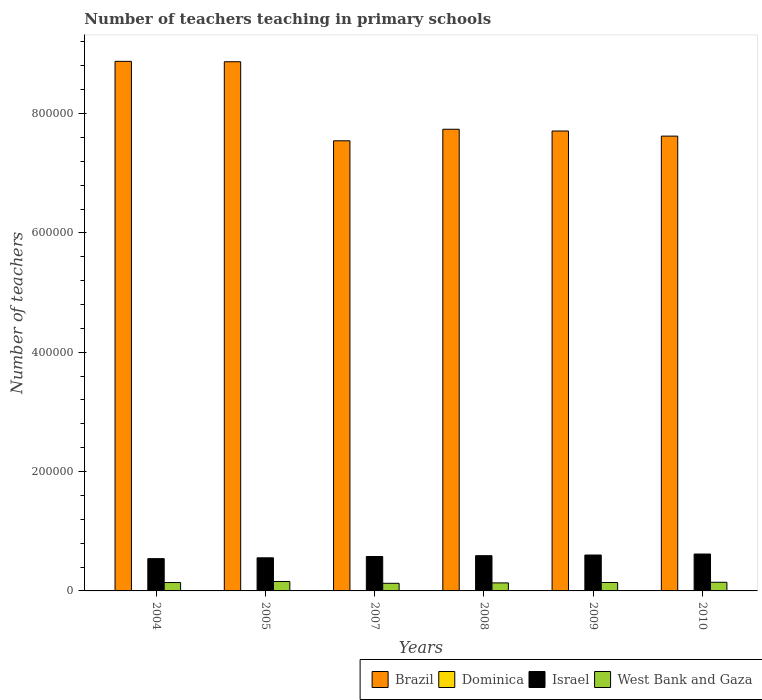Are the number of bars per tick equal to the number of legend labels?
Offer a terse response. Yes. Are the number of bars on each tick of the X-axis equal?
Provide a succinct answer. Yes. How many bars are there on the 6th tick from the right?
Ensure brevity in your answer.  4. What is the label of the 6th group of bars from the left?
Keep it short and to the point. 2010. What is the number of teachers teaching in primary schools in West Bank and Gaza in 2007?
Your response must be concise. 1.28e+04. Across all years, what is the maximum number of teachers teaching in primary schools in Dominica?
Ensure brevity in your answer.  519. Across all years, what is the minimum number of teachers teaching in primary schools in Dominica?
Give a very brief answer. 499. In which year was the number of teachers teaching in primary schools in West Bank and Gaza minimum?
Keep it short and to the point. 2007. What is the total number of teachers teaching in primary schools in Brazil in the graph?
Ensure brevity in your answer.  4.83e+06. What is the difference between the number of teachers teaching in primary schools in Brazil in 2005 and that in 2007?
Provide a short and direct response. 1.32e+05. What is the difference between the number of teachers teaching in primary schools in Brazil in 2005 and the number of teachers teaching in primary schools in Israel in 2009?
Your answer should be compact. 8.27e+05. What is the average number of teachers teaching in primary schools in Dominica per year?
Your answer should be very brief. 509.17. In the year 2005, what is the difference between the number of teachers teaching in primary schools in West Bank and Gaza and number of teachers teaching in primary schools in Israel?
Your answer should be compact. -3.97e+04. What is the ratio of the number of teachers teaching in primary schools in West Bank and Gaza in 2004 to that in 2010?
Ensure brevity in your answer.  0.97. What is the difference between the highest and the second highest number of teachers teaching in primary schools in Israel?
Give a very brief answer. 1675. What is the difference between the highest and the lowest number of teachers teaching in primary schools in Brazil?
Provide a short and direct response. 1.33e+05. Is the sum of the number of teachers teaching in primary schools in Israel in 2005 and 2007 greater than the maximum number of teachers teaching in primary schools in Brazil across all years?
Ensure brevity in your answer.  No. Is it the case that in every year, the sum of the number of teachers teaching in primary schools in West Bank and Gaza and number of teachers teaching in primary schools in Dominica is greater than the sum of number of teachers teaching in primary schools in Brazil and number of teachers teaching in primary schools in Israel?
Offer a terse response. No. What does the 2nd bar from the left in 2007 represents?
Keep it short and to the point. Dominica. What does the 1st bar from the right in 2007 represents?
Provide a short and direct response. West Bank and Gaza. How many bars are there?
Offer a very short reply. 24. How many years are there in the graph?
Make the answer very short. 6. Does the graph contain any zero values?
Offer a very short reply. No. Does the graph contain grids?
Your answer should be very brief. No. What is the title of the graph?
Offer a very short reply. Number of teachers teaching in primary schools. What is the label or title of the Y-axis?
Your response must be concise. Number of teachers. What is the Number of teachers in Brazil in 2004?
Provide a succinct answer. 8.87e+05. What is the Number of teachers of Dominica in 2004?
Offer a terse response. 519. What is the Number of teachers in Israel in 2004?
Your answer should be compact. 5.41e+04. What is the Number of teachers in West Bank and Gaza in 2004?
Keep it short and to the point. 1.40e+04. What is the Number of teachers in Brazil in 2005?
Ensure brevity in your answer.  8.87e+05. What is the Number of teachers of Dominica in 2005?
Your answer should be very brief. 519. What is the Number of teachers in Israel in 2005?
Ensure brevity in your answer.  5.55e+04. What is the Number of teachers in West Bank and Gaza in 2005?
Keep it short and to the point. 1.58e+04. What is the Number of teachers of Brazil in 2007?
Your response must be concise. 7.54e+05. What is the Number of teachers in Dominica in 2007?
Keep it short and to the point. 499. What is the Number of teachers of Israel in 2007?
Offer a very short reply. 5.77e+04. What is the Number of teachers in West Bank and Gaza in 2007?
Ensure brevity in your answer.  1.28e+04. What is the Number of teachers in Brazil in 2008?
Provide a succinct answer. 7.74e+05. What is the Number of teachers in Israel in 2008?
Keep it short and to the point. 5.91e+04. What is the Number of teachers of West Bank and Gaza in 2008?
Offer a terse response. 1.34e+04. What is the Number of teachers of Brazil in 2009?
Give a very brief answer. 7.71e+05. What is the Number of teachers of Dominica in 2009?
Ensure brevity in your answer.  510. What is the Number of teachers of Israel in 2009?
Offer a very short reply. 6.02e+04. What is the Number of teachers of West Bank and Gaza in 2009?
Your answer should be very brief. 1.41e+04. What is the Number of teachers in Brazil in 2010?
Your answer should be very brief. 7.62e+05. What is the Number of teachers in Dominica in 2010?
Offer a very short reply. 508. What is the Number of teachers in Israel in 2010?
Give a very brief answer. 6.18e+04. What is the Number of teachers of West Bank and Gaza in 2010?
Your answer should be compact. 1.45e+04. Across all years, what is the maximum Number of teachers in Brazil?
Ensure brevity in your answer.  8.87e+05. Across all years, what is the maximum Number of teachers of Dominica?
Your answer should be very brief. 519. Across all years, what is the maximum Number of teachers of Israel?
Give a very brief answer. 6.18e+04. Across all years, what is the maximum Number of teachers of West Bank and Gaza?
Ensure brevity in your answer.  1.58e+04. Across all years, what is the minimum Number of teachers of Brazil?
Keep it short and to the point. 7.54e+05. Across all years, what is the minimum Number of teachers of Dominica?
Your answer should be very brief. 499. Across all years, what is the minimum Number of teachers of Israel?
Give a very brief answer. 5.41e+04. Across all years, what is the minimum Number of teachers in West Bank and Gaza?
Your answer should be very brief. 1.28e+04. What is the total Number of teachers of Brazil in the graph?
Offer a terse response. 4.83e+06. What is the total Number of teachers in Dominica in the graph?
Offer a very short reply. 3055. What is the total Number of teachers of Israel in the graph?
Offer a terse response. 3.48e+05. What is the total Number of teachers of West Bank and Gaza in the graph?
Offer a very short reply. 8.47e+04. What is the difference between the Number of teachers in Brazil in 2004 and that in 2005?
Your response must be concise. 647. What is the difference between the Number of teachers of Dominica in 2004 and that in 2005?
Offer a terse response. 0. What is the difference between the Number of teachers of Israel in 2004 and that in 2005?
Your response must be concise. -1339. What is the difference between the Number of teachers in West Bank and Gaza in 2004 and that in 2005?
Offer a terse response. -1740. What is the difference between the Number of teachers of Brazil in 2004 and that in 2007?
Offer a terse response. 1.33e+05. What is the difference between the Number of teachers in Israel in 2004 and that in 2007?
Give a very brief answer. -3547. What is the difference between the Number of teachers of West Bank and Gaza in 2004 and that in 2007?
Your answer should be compact. 1297. What is the difference between the Number of teachers in Brazil in 2004 and that in 2008?
Provide a succinct answer. 1.14e+05. What is the difference between the Number of teachers in Dominica in 2004 and that in 2008?
Your response must be concise. 19. What is the difference between the Number of teachers of Israel in 2004 and that in 2008?
Your answer should be very brief. -4943. What is the difference between the Number of teachers in West Bank and Gaza in 2004 and that in 2008?
Your response must be concise. 601. What is the difference between the Number of teachers in Brazil in 2004 and that in 2009?
Your answer should be compact. 1.17e+05. What is the difference between the Number of teachers in Israel in 2004 and that in 2009?
Your answer should be very brief. -6036. What is the difference between the Number of teachers in West Bank and Gaza in 2004 and that in 2009?
Ensure brevity in your answer.  -87. What is the difference between the Number of teachers of Brazil in 2004 and that in 2010?
Ensure brevity in your answer.  1.25e+05. What is the difference between the Number of teachers of Israel in 2004 and that in 2010?
Your answer should be very brief. -7711. What is the difference between the Number of teachers of West Bank and Gaza in 2004 and that in 2010?
Make the answer very short. -442. What is the difference between the Number of teachers in Brazil in 2005 and that in 2007?
Ensure brevity in your answer.  1.32e+05. What is the difference between the Number of teachers in Dominica in 2005 and that in 2007?
Provide a short and direct response. 20. What is the difference between the Number of teachers in Israel in 2005 and that in 2007?
Keep it short and to the point. -2208. What is the difference between the Number of teachers of West Bank and Gaza in 2005 and that in 2007?
Provide a short and direct response. 3037. What is the difference between the Number of teachers of Brazil in 2005 and that in 2008?
Ensure brevity in your answer.  1.13e+05. What is the difference between the Number of teachers in Israel in 2005 and that in 2008?
Offer a terse response. -3604. What is the difference between the Number of teachers of West Bank and Gaza in 2005 and that in 2008?
Offer a very short reply. 2341. What is the difference between the Number of teachers of Brazil in 2005 and that in 2009?
Ensure brevity in your answer.  1.16e+05. What is the difference between the Number of teachers of Dominica in 2005 and that in 2009?
Provide a succinct answer. 9. What is the difference between the Number of teachers of Israel in 2005 and that in 2009?
Ensure brevity in your answer.  -4697. What is the difference between the Number of teachers of West Bank and Gaza in 2005 and that in 2009?
Your answer should be compact. 1653. What is the difference between the Number of teachers of Brazil in 2005 and that in 2010?
Your answer should be compact. 1.25e+05. What is the difference between the Number of teachers in Israel in 2005 and that in 2010?
Give a very brief answer. -6372. What is the difference between the Number of teachers in West Bank and Gaza in 2005 and that in 2010?
Your answer should be very brief. 1298. What is the difference between the Number of teachers of Brazil in 2007 and that in 2008?
Make the answer very short. -1.93e+04. What is the difference between the Number of teachers in Israel in 2007 and that in 2008?
Give a very brief answer. -1396. What is the difference between the Number of teachers in West Bank and Gaza in 2007 and that in 2008?
Offer a very short reply. -696. What is the difference between the Number of teachers of Brazil in 2007 and that in 2009?
Give a very brief answer. -1.64e+04. What is the difference between the Number of teachers of Dominica in 2007 and that in 2009?
Offer a terse response. -11. What is the difference between the Number of teachers of Israel in 2007 and that in 2009?
Your answer should be compact. -2489. What is the difference between the Number of teachers in West Bank and Gaza in 2007 and that in 2009?
Make the answer very short. -1384. What is the difference between the Number of teachers of Brazil in 2007 and that in 2010?
Your response must be concise. -7841. What is the difference between the Number of teachers of Dominica in 2007 and that in 2010?
Ensure brevity in your answer.  -9. What is the difference between the Number of teachers in Israel in 2007 and that in 2010?
Make the answer very short. -4164. What is the difference between the Number of teachers in West Bank and Gaza in 2007 and that in 2010?
Offer a terse response. -1739. What is the difference between the Number of teachers of Brazil in 2008 and that in 2009?
Give a very brief answer. 2921. What is the difference between the Number of teachers in Israel in 2008 and that in 2009?
Ensure brevity in your answer.  -1093. What is the difference between the Number of teachers of West Bank and Gaza in 2008 and that in 2009?
Give a very brief answer. -688. What is the difference between the Number of teachers of Brazil in 2008 and that in 2010?
Your answer should be compact. 1.15e+04. What is the difference between the Number of teachers of Dominica in 2008 and that in 2010?
Ensure brevity in your answer.  -8. What is the difference between the Number of teachers in Israel in 2008 and that in 2010?
Provide a succinct answer. -2768. What is the difference between the Number of teachers of West Bank and Gaza in 2008 and that in 2010?
Give a very brief answer. -1043. What is the difference between the Number of teachers of Brazil in 2009 and that in 2010?
Keep it short and to the point. 8571. What is the difference between the Number of teachers in Israel in 2009 and that in 2010?
Provide a succinct answer. -1675. What is the difference between the Number of teachers in West Bank and Gaza in 2009 and that in 2010?
Your response must be concise. -355. What is the difference between the Number of teachers in Brazil in 2004 and the Number of teachers in Dominica in 2005?
Keep it short and to the point. 8.87e+05. What is the difference between the Number of teachers in Brazil in 2004 and the Number of teachers in Israel in 2005?
Offer a very short reply. 8.32e+05. What is the difference between the Number of teachers of Brazil in 2004 and the Number of teachers of West Bank and Gaza in 2005?
Make the answer very short. 8.72e+05. What is the difference between the Number of teachers of Dominica in 2004 and the Number of teachers of Israel in 2005?
Offer a very short reply. -5.49e+04. What is the difference between the Number of teachers in Dominica in 2004 and the Number of teachers in West Bank and Gaza in 2005?
Give a very brief answer. -1.53e+04. What is the difference between the Number of teachers in Israel in 2004 and the Number of teachers in West Bank and Gaza in 2005?
Offer a very short reply. 3.83e+04. What is the difference between the Number of teachers of Brazil in 2004 and the Number of teachers of Dominica in 2007?
Keep it short and to the point. 8.87e+05. What is the difference between the Number of teachers in Brazil in 2004 and the Number of teachers in Israel in 2007?
Provide a short and direct response. 8.30e+05. What is the difference between the Number of teachers of Brazil in 2004 and the Number of teachers of West Bank and Gaza in 2007?
Your response must be concise. 8.75e+05. What is the difference between the Number of teachers in Dominica in 2004 and the Number of teachers in Israel in 2007?
Offer a very short reply. -5.71e+04. What is the difference between the Number of teachers in Dominica in 2004 and the Number of teachers in West Bank and Gaza in 2007?
Provide a succinct answer. -1.22e+04. What is the difference between the Number of teachers of Israel in 2004 and the Number of teachers of West Bank and Gaza in 2007?
Provide a short and direct response. 4.14e+04. What is the difference between the Number of teachers in Brazil in 2004 and the Number of teachers in Dominica in 2008?
Keep it short and to the point. 8.87e+05. What is the difference between the Number of teachers in Brazil in 2004 and the Number of teachers in Israel in 2008?
Your answer should be compact. 8.28e+05. What is the difference between the Number of teachers in Brazil in 2004 and the Number of teachers in West Bank and Gaza in 2008?
Keep it short and to the point. 8.74e+05. What is the difference between the Number of teachers in Dominica in 2004 and the Number of teachers in Israel in 2008?
Ensure brevity in your answer.  -5.85e+04. What is the difference between the Number of teachers of Dominica in 2004 and the Number of teachers of West Bank and Gaza in 2008?
Your answer should be compact. -1.29e+04. What is the difference between the Number of teachers of Israel in 2004 and the Number of teachers of West Bank and Gaza in 2008?
Ensure brevity in your answer.  4.07e+04. What is the difference between the Number of teachers in Brazil in 2004 and the Number of teachers in Dominica in 2009?
Provide a succinct answer. 8.87e+05. What is the difference between the Number of teachers in Brazil in 2004 and the Number of teachers in Israel in 2009?
Keep it short and to the point. 8.27e+05. What is the difference between the Number of teachers in Brazil in 2004 and the Number of teachers in West Bank and Gaza in 2009?
Your answer should be compact. 8.73e+05. What is the difference between the Number of teachers of Dominica in 2004 and the Number of teachers of Israel in 2009?
Offer a very short reply. -5.96e+04. What is the difference between the Number of teachers of Dominica in 2004 and the Number of teachers of West Bank and Gaza in 2009?
Make the answer very short. -1.36e+04. What is the difference between the Number of teachers in Israel in 2004 and the Number of teachers in West Bank and Gaza in 2009?
Your answer should be very brief. 4.00e+04. What is the difference between the Number of teachers of Brazil in 2004 and the Number of teachers of Dominica in 2010?
Offer a very short reply. 8.87e+05. What is the difference between the Number of teachers of Brazil in 2004 and the Number of teachers of Israel in 2010?
Your response must be concise. 8.26e+05. What is the difference between the Number of teachers of Brazil in 2004 and the Number of teachers of West Bank and Gaza in 2010?
Give a very brief answer. 8.73e+05. What is the difference between the Number of teachers in Dominica in 2004 and the Number of teachers in Israel in 2010?
Your answer should be compact. -6.13e+04. What is the difference between the Number of teachers in Dominica in 2004 and the Number of teachers in West Bank and Gaza in 2010?
Offer a very short reply. -1.40e+04. What is the difference between the Number of teachers of Israel in 2004 and the Number of teachers of West Bank and Gaza in 2010?
Keep it short and to the point. 3.96e+04. What is the difference between the Number of teachers of Brazil in 2005 and the Number of teachers of Dominica in 2007?
Keep it short and to the point. 8.86e+05. What is the difference between the Number of teachers of Brazil in 2005 and the Number of teachers of Israel in 2007?
Offer a terse response. 8.29e+05. What is the difference between the Number of teachers of Brazil in 2005 and the Number of teachers of West Bank and Gaza in 2007?
Provide a short and direct response. 8.74e+05. What is the difference between the Number of teachers of Dominica in 2005 and the Number of teachers of Israel in 2007?
Your response must be concise. -5.71e+04. What is the difference between the Number of teachers of Dominica in 2005 and the Number of teachers of West Bank and Gaza in 2007?
Your answer should be very brief. -1.22e+04. What is the difference between the Number of teachers in Israel in 2005 and the Number of teachers in West Bank and Gaza in 2007?
Offer a very short reply. 4.27e+04. What is the difference between the Number of teachers of Brazil in 2005 and the Number of teachers of Dominica in 2008?
Give a very brief answer. 8.86e+05. What is the difference between the Number of teachers in Brazil in 2005 and the Number of teachers in Israel in 2008?
Make the answer very short. 8.28e+05. What is the difference between the Number of teachers in Brazil in 2005 and the Number of teachers in West Bank and Gaza in 2008?
Offer a very short reply. 8.73e+05. What is the difference between the Number of teachers in Dominica in 2005 and the Number of teachers in Israel in 2008?
Ensure brevity in your answer.  -5.85e+04. What is the difference between the Number of teachers of Dominica in 2005 and the Number of teachers of West Bank and Gaza in 2008?
Ensure brevity in your answer.  -1.29e+04. What is the difference between the Number of teachers of Israel in 2005 and the Number of teachers of West Bank and Gaza in 2008?
Keep it short and to the point. 4.20e+04. What is the difference between the Number of teachers in Brazil in 2005 and the Number of teachers in Dominica in 2009?
Your answer should be compact. 8.86e+05. What is the difference between the Number of teachers of Brazil in 2005 and the Number of teachers of Israel in 2009?
Your response must be concise. 8.27e+05. What is the difference between the Number of teachers in Brazil in 2005 and the Number of teachers in West Bank and Gaza in 2009?
Offer a terse response. 8.73e+05. What is the difference between the Number of teachers of Dominica in 2005 and the Number of teachers of Israel in 2009?
Your answer should be very brief. -5.96e+04. What is the difference between the Number of teachers of Dominica in 2005 and the Number of teachers of West Bank and Gaza in 2009?
Give a very brief answer. -1.36e+04. What is the difference between the Number of teachers of Israel in 2005 and the Number of teachers of West Bank and Gaza in 2009?
Provide a short and direct response. 4.13e+04. What is the difference between the Number of teachers in Brazil in 2005 and the Number of teachers in Dominica in 2010?
Your answer should be compact. 8.86e+05. What is the difference between the Number of teachers of Brazil in 2005 and the Number of teachers of Israel in 2010?
Provide a succinct answer. 8.25e+05. What is the difference between the Number of teachers of Brazil in 2005 and the Number of teachers of West Bank and Gaza in 2010?
Provide a short and direct response. 8.72e+05. What is the difference between the Number of teachers of Dominica in 2005 and the Number of teachers of Israel in 2010?
Keep it short and to the point. -6.13e+04. What is the difference between the Number of teachers of Dominica in 2005 and the Number of teachers of West Bank and Gaza in 2010?
Your answer should be compact. -1.40e+04. What is the difference between the Number of teachers in Israel in 2005 and the Number of teachers in West Bank and Gaza in 2010?
Give a very brief answer. 4.10e+04. What is the difference between the Number of teachers of Brazil in 2007 and the Number of teachers of Dominica in 2008?
Provide a succinct answer. 7.54e+05. What is the difference between the Number of teachers in Brazil in 2007 and the Number of teachers in Israel in 2008?
Ensure brevity in your answer.  6.95e+05. What is the difference between the Number of teachers of Brazil in 2007 and the Number of teachers of West Bank and Gaza in 2008?
Keep it short and to the point. 7.41e+05. What is the difference between the Number of teachers in Dominica in 2007 and the Number of teachers in Israel in 2008?
Your answer should be compact. -5.86e+04. What is the difference between the Number of teachers of Dominica in 2007 and the Number of teachers of West Bank and Gaza in 2008?
Your answer should be very brief. -1.29e+04. What is the difference between the Number of teachers of Israel in 2007 and the Number of teachers of West Bank and Gaza in 2008?
Give a very brief answer. 4.42e+04. What is the difference between the Number of teachers in Brazil in 2007 and the Number of teachers in Dominica in 2009?
Your response must be concise. 7.54e+05. What is the difference between the Number of teachers of Brazil in 2007 and the Number of teachers of Israel in 2009?
Your response must be concise. 6.94e+05. What is the difference between the Number of teachers of Brazil in 2007 and the Number of teachers of West Bank and Gaza in 2009?
Offer a terse response. 7.40e+05. What is the difference between the Number of teachers of Dominica in 2007 and the Number of teachers of Israel in 2009?
Your response must be concise. -5.97e+04. What is the difference between the Number of teachers in Dominica in 2007 and the Number of teachers in West Bank and Gaza in 2009?
Your answer should be very brief. -1.36e+04. What is the difference between the Number of teachers of Israel in 2007 and the Number of teachers of West Bank and Gaza in 2009?
Provide a succinct answer. 4.35e+04. What is the difference between the Number of teachers in Brazil in 2007 and the Number of teachers in Dominica in 2010?
Ensure brevity in your answer.  7.54e+05. What is the difference between the Number of teachers in Brazil in 2007 and the Number of teachers in Israel in 2010?
Your answer should be compact. 6.92e+05. What is the difference between the Number of teachers of Brazil in 2007 and the Number of teachers of West Bank and Gaza in 2010?
Ensure brevity in your answer.  7.40e+05. What is the difference between the Number of teachers of Dominica in 2007 and the Number of teachers of Israel in 2010?
Offer a very short reply. -6.13e+04. What is the difference between the Number of teachers of Dominica in 2007 and the Number of teachers of West Bank and Gaza in 2010?
Ensure brevity in your answer.  -1.40e+04. What is the difference between the Number of teachers in Israel in 2007 and the Number of teachers in West Bank and Gaza in 2010?
Provide a succinct answer. 4.32e+04. What is the difference between the Number of teachers of Brazil in 2008 and the Number of teachers of Dominica in 2009?
Give a very brief answer. 7.73e+05. What is the difference between the Number of teachers of Brazil in 2008 and the Number of teachers of Israel in 2009?
Make the answer very short. 7.13e+05. What is the difference between the Number of teachers of Brazil in 2008 and the Number of teachers of West Bank and Gaza in 2009?
Your answer should be compact. 7.59e+05. What is the difference between the Number of teachers in Dominica in 2008 and the Number of teachers in Israel in 2009?
Give a very brief answer. -5.97e+04. What is the difference between the Number of teachers of Dominica in 2008 and the Number of teachers of West Bank and Gaza in 2009?
Keep it short and to the point. -1.36e+04. What is the difference between the Number of teachers in Israel in 2008 and the Number of teachers in West Bank and Gaza in 2009?
Offer a terse response. 4.49e+04. What is the difference between the Number of teachers of Brazil in 2008 and the Number of teachers of Dominica in 2010?
Your answer should be compact. 7.73e+05. What is the difference between the Number of teachers in Brazil in 2008 and the Number of teachers in Israel in 2010?
Your answer should be very brief. 7.12e+05. What is the difference between the Number of teachers of Brazil in 2008 and the Number of teachers of West Bank and Gaza in 2010?
Offer a very short reply. 7.59e+05. What is the difference between the Number of teachers in Dominica in 2008 and the Number of teachers in Israel in 2010?
Your response must be concise. -6.13e+04. What is the difference between the Number of teachers in Dominica in 2008 and the Number of teachers in West Bank and Gaza in 2010?
Your answer should be very brief. -1.40e+04. What is the difference between the Number of teachers of Israel in 2008 and the Number of teachers of West Bank and Gaza in 2010?
Keep it short and to the point. 4.46e+04. What is the difference between the Number of teachers in Brazil in 2009 and the Number of teachers in Dominica in 2010?
Your response must be concise. 7.70e+05. What is the difference between the Number of teachers in Brazil in 2009 and the Number of teachers in Israel in 2010?
Provide a succinct answer. 7.09e+05. What is the difference between the Number of teachers in Brazil in 2009 and the Number of teachers in West Bank and Gaza in 2010?
Offer a terse response. 7.56e+05. What is the difference between the Number of teachers in Dominica in 2009 and the Number of teachers in Israel in 2010?
Ensure brevity in your answer.  -6.13e+04. What is the difference between the Number of teachers in Dominica in 2009 and the Number of teachers in West Bank and Gaza in 2010?
Provide a short and direct response. -1.40e+04. What is the difference between the Number of teachers of Israel in 2009 and the Number of teachers of West Bank and Gaza in 2010?
Your response must be concise. 4.57e+04. What is the average Number of teachers of Brazil per year?
Your answer should be compact. 8.06e+05. What is the average Number of teachers of Dominica per year?
Offer a very short reply. 509.17. What is the average Number of teachers of Israel per year?
Your answer should be compact. 5.80e+04. What is the average Number of teachers of West Bank and Gaza per year?
Ensure brevity in your answer.  1.41e+04. In the year 2004, what is the difference between the Number of teachers of Brazil and Number of teachers of Dominica?
Provide a succinct answer. 8.87e+05. In the year 2004, what is the difference between the Number of teachers in Brazil and Number of teachers in Israel?
Provide a succinct answer. 8.33e+05. In the year 2004, what is the difference between the Number of teachers in Brazil and Number of teachers in West Bank and Gaza?
Provide a short and direct response. 8.73e+05. In the year 2004, what is the difference between the Number of teachers of Dominica and Number of teachers of Israel?
Offer a very short reply. -5.36e+04. In the year 2004, what is the difference between the Number of teachers in Dominica and Number of teachers in West Bank and Gaza?
Your response must be concise. -1.35e+04. In the year 2004, what is the difference between the Number of teachers of Israel and Number of teachers of West Bank and Gaza?
Keep it short and to the point. 4.01e+04. In the year 2005, what is the difference between the Number of teachers in Brazil and Number of teachers in Dominica?
Keep it short and to the point. 8.86e+05. In the year 2005, what is the difference between the Number of teachers in Brazil and Number of teachers in Israel?
Keep it short and to the point. 8.31e+05. In the year 2005, what is the difference between the Number of teachers of Brazil and Number of teachers of West Bank and Gaza?
Ensure brevity in your answer.  8.71e+05. In the year 2005, what is the difference between the Number of teachers in Dominica and Number of teachers in Israel?
Make the answer very short. -5.49e+04. In the year 2005, what is the difference between the Number of teachers of Dominica and Number of teachers of West Bank and Gaza?
Make the answer very short. -1.53e+04. In the year 2005, what is the difference between the Number of teachers in Israel and Number of teachers in West Bank and Gaza?
Provide a succinct answer. 3.97e+04. In the year 2007, what is the difference between the Number of teachers of Brazil and Number of teachers of Dominica?
Make the answer very short. 7.54e+05. In the year 2007, what is the difference between the Number of teachers of Brazil and Number of teachers of Israel?
Your answer should be compact. 6.97e+05. In the year 2007, what is the difference between the Number of teachers of Brazil and Number of teachers of West Bank and Gaza?
Keep it short and to the point. 7.42e+05. In the year 2007, what is the difference between the Number of teachers of Dominica and Number of teachers of Israel?
Keep it short and to the point. -5.72e+04. In the year 2007, what is the difference between the Number of teachers of Dominica and Number of teachers of West Bank and Gaza?
Ensure brevity in your answer.  -1.23e+04. In the year 2007, what is the difference between the Number of teachers in Israel and Number of teachers in West Bank and Gaza?
Provide a short and direct response. 4.49e+04. In the year 2008, what is the difference between the Number of teachers of Brazil and Number of teachers of Dominica?
Ensure brevity in your answer.  7.73e+05. In the year 2008, what is the difference between the Number of teachers of Brazil and Number of teachers of Israel?
Your answer should be compact. 7.15e+05. In the year 2008, what is the difference between the Number of teachers of Brazil and Number of teachers of West Bank and Gaza?
Provide a short and direct response. 7.60e+05. In the year 2008, what is the difference between the Number of teachers in Dominica and Number of teachers in Israel?
Ensure brevity in your answer.  -5.86e+04. In the year 2008, what is the difference between the Number of teachers in Dominica and Number of teachers in West Bank and Gaza?
Offer a very short reply. -1.29e+04. In the year 2008, what is the difference between the Number of teachers of Israel and Number of teachers of West Bank and Gaza?
Your response must be concise. 4.56e+04. In the year 2009, what is the difference between the Number of teachers of Brazil and Number of teachers of Dominica?
Provide a short and direct response. 7.70e+05. In the year 2009, what is the difference between the Number of teachers of Brazil and Number of teachers of Israel?
Keep it short and to the point. 7.11e+05. In the year 2009, what is the difference between the Number of teachers of Brazil and Number of teachers of West Bank and Gaza?
Your answer should be compact. 7.57e+05. In the year 2009, what is the difference between the Number of teachers in Dominica and Number of teachers in Israel?
Ensure brevity in your answer.  -5.96e+04. In the year 2009, what is the difference between the Number of teachers in Dominica and Number of teachers in West Bank and Gaza?
Your response must be concise. -1.36e+04. In the year 2009, what is the difference between the Number of teachers of Israel and Number of teachers of West Bank and Gaza?
Provide a short and direct response. 4.60e+04. In the year 2010, what is the difference between the Number of teachers of Brazil and Number of teachers of Dominica?
Provide a short and direct response. 7.62e+05. In the year 2010, what is the difference between the Number of teachers of Brazil and Number of teachers of Israel?
Your response must be concise. 7.00e+05. In the year 2010, what is the difference between the Number of teachers in Brazil and Number of teachers in West Bank and Gaza?
Provide a short and direct response. 7.48e+05. In the year 2010, what is the difference between the Number of teachers of Dominica and Number of teachers of Israel?
Offer a very short reply. -6.13e+04. In the year 2010, what is the difference between the Number of teachers in Dominica and Number of teachers in West Bank and Gaza?
Your answer should be compact. -1.40e+04. In the year 2010, what is the difference between the Number of teachers of Israel and Number of teachers of West Bank and Gaza?
Your answer should be very brief. 4.73e+04. What is the ratio of the Number of teachers in Brazil in 2004 to that in 2005?
Provide a short and direct response. 1. What is the ratio of the Number of teachers of Dominica in 2004 to that in 2005?
Give a very brief answer. 1. What is the ratio of the Number of teachers of Israel in 2004 to that in 2005?
Ensure brevity in your answer.  0.98. What is the ratio of the Number of teachers of West Bank and Gaza in 2004 to that in 2005?
Make the answer very short. 0.89. What is the ratio of the Number of teachers in Brazil in 2004 to that in 2007?
Make the answer very short. 1.18. What is the ratio of the Number of teachers of Dominica in 2004 to that in 2007?
Ensure brevity in your answer.  1.04. What is the ratio of the Number of teachers in Israel in 2004 to that in 2007?
Make the answer very short. 0.94. What is the ratio of the Number of teachers of West Bank and Gaza in 2004 to that in 2007?
Your response must be concise. 1.1. What is the ratio of the Number of teachers of Brazil in 2004 to that in 2008?
Offer a terse response. 1.15. What is the ratio of the Number of teachers in Dominica in 2004 to that in 2008?
Keep it short and to the point. 1.04. What is the ratio of the Number of teachers of Israel in 2004 to that in 2008?
Keep it short and to the point. 0.92. What is the ratio of the Number of teachers of West Bank and Gaza in 2004 to that in 2008?
Give a very brief answer. 1.04. What is the ratio of the Number of teachers of Brazil in 2004 to that in 2009?
Your answer should be compact. 1.15. What is the ratio of the Number of teachers in Dominica in 2004 to that in 2009?
Provide a short and direct response. 1.02. What is the ratio of the Number of teachers of Israel in 2004 to that in 2009?
Ensure brevity in your answer.  0.9. What is the ratio of the Number of teachers in Brazil in 2004 to that in 2010?
Make the answer very short. 1.16. What is the ratio of the Number of teachers of Dominica in 2004 to that in 2010?
Make the answer very short. 1.02. What is the ratio of the Number of teachers of Israel in 2004 to that in 2010?
Make the answer very short. 0.88. What is the ratio of the Number of teachers of West Bank and Gaza in 2004 to that in 2010?
Ensure brevity in your answer.  0.97. What is the ratio of the Number of teachers in Brazil in 2005 to that in 2007?
Keep it short and to the point. 1.18. What is the ratio of the Number of teachers in Dominica in 2005 to that in 2007?
Provide a succinct answer. 1.04. What is the ratio of the Number of teachers in Israel in 2005 to that in 2007?
Give a very brief answer. 0.96. What is the ratio of the Number of teachers in West Bank and Gaza in 2005 to that in 2007?
Ensure brevity in your answer.  1.24. What is the ratio of the Number of teachers in Brazil in 2005 to that in 2008?
Ensure brevity in your answer.  1.15. What is the ratio of the Number of teachers in Dominica in 2005 to that in 2008?
Keep it short and to the point. 1.04. What is the ratio of the Number of teachers in Israel in 2005 to that in 2008?
Give a very brief answer. 0.94. What is the ratio of the Number of teachers of West Bank and Gaza in 2005 to that in 2008?
Provide a succinct answer. 1.17. What is the ratio of the Number of teachers in Brazil in 2005 to that in 2009?
Make the answer very short. 1.15. What is the ratio of the Number of teachers of Dominica in 2005 to that in 2009?
Offer a terse response. 1.02. What is the ratio of the Number of teachers of Israel in 2005 to that in 2009?
Offer a very short reply. 0.92. What is the ratio of the Number of teachers of West Bank and Gaza in 2005 to that in 2009?
Your answer should be very brief. 1.12. What is the ratio of the Number of teachers of Brazil in 2005 to that in 2010?
Offer a very short reply. 1.16. What is the ratio of the Number of teachers in Dominica in 2005 to that in 2010?
Make the answer very short. 1.02. What is the ratio of the Number of teachers of Israel in 2005 to that in 2010?
Offer a very short reply. 0.9. What is the ratio of the Number of teachers in West Bank and Gaza in 2005 to that in 2010?
Ensure brevity in your answer.  1.09. What is the ratio of the Number of teachers in Dominica in 2007 to that in 2008?
Give a very brief answer. 1. What is the ratio of the Number of teachers in Israel in 2007 to that in 2008?
Your answer should be very brief. 0.98. What is the ratio of the Number of teachers of West Bank and Gaza in 2007 to that in 2008?
Offer a very short reply. 0.95. What is the ratio of the Number of teachers in Brazil in 2007 to that in 2009?
Give a very brief answer. 0.98. What is the ratio of the Number of teachers in Dominica in 2007 to that in 2009?
Ensure brevity in your answer.  0.98. What is the ratio of the Number of teachers of Israel in 2007 to that in 2009?
Your response must be concise. 0.96. What is the ratio of the Number of teachers in West Bank and Gaza in 2007 to that in 2009?
Make the answer very short. 0.9. What is the ratio of the Number of teachers in Dominica in 2007 to that in 2010?
Make the answer very short. 0.98. What is the ratio of the Number of teachers of Israel in 2007 to that in 2010?
Offer a terse response. 0.93. What is the ratio of the Number of teachers in Brazil in 2008 to that in 2009?
Make the answer very short. 1. What is the ratio of the Number of teachers in Dominica in 2008 to that in 2009?
Offer a terse response. 0.98. What is the ratio of the Number of teachers of Israel in 2008 to that in 2009?
Your answer should be compact. 0.98. What is the ratio of the Number of teachers of West Bank and Gaza in 2008 to that in 2009?
Your response must be concise. 0.95. What is the ratio of the Number of teachers in Brazil in 2008 to that in 2010?
Offer a very short reply. 1.02. What is the ratio of the Number of teachers in Dominica in 2008 to that in 2010?
Make the answer very short. 0.98. What is the ratio of the Number of teachers of Israel in 2008 to that in 2010?
Offer a terse response. 0.96. What is the ratio of the Number of teachers of West Bank and Gaza in 2008 to that in 2010?
Offer a very short reply. 0.93. What is the ratio of the Number of teachers in Brazil in 2009 to that in 2010?
Give a very brief answer. 1.01. What is the ratio of the Number of teachers of Dominica in 2009 to that in 2010?
Keep it short and to the point. 1. What is the ratio of the Number of teachers in Israel in 2009 to that in 2010?
Keep it short and to the point. 0.97. What is the ratio of the Number of teachers of West Bank and Gaza in 2009 to that in 2010?
Your answer should be very brief. 0.98. What is the difference between the highest and the second highest Number of teachers of Brazil?
Provide a short and direct response. 647. What is the difference between the highest and the second highest Number of teachers of Israel?
Provide a short and direct response. 1675. What is the difference between the highest and the second highest Number of teachers in West Bank and Gaza?
Make the answer very short. 1298. What is the difference between the highest and the lowest Number of teachers of Brazil?
Your response must be concise. 1.33e+05. What is the difference between the highest and the lowest Number of teachers in Dominica?
Your answer should be compact. 20. What is the difference between the highest and the lowest Number of teachers in Israel?
Keep it short and to the point. 7711. What is the difference between the highest and the lowest Number of teachers in West Bank and Gaza?
Provide a short and direct response. 3037. 